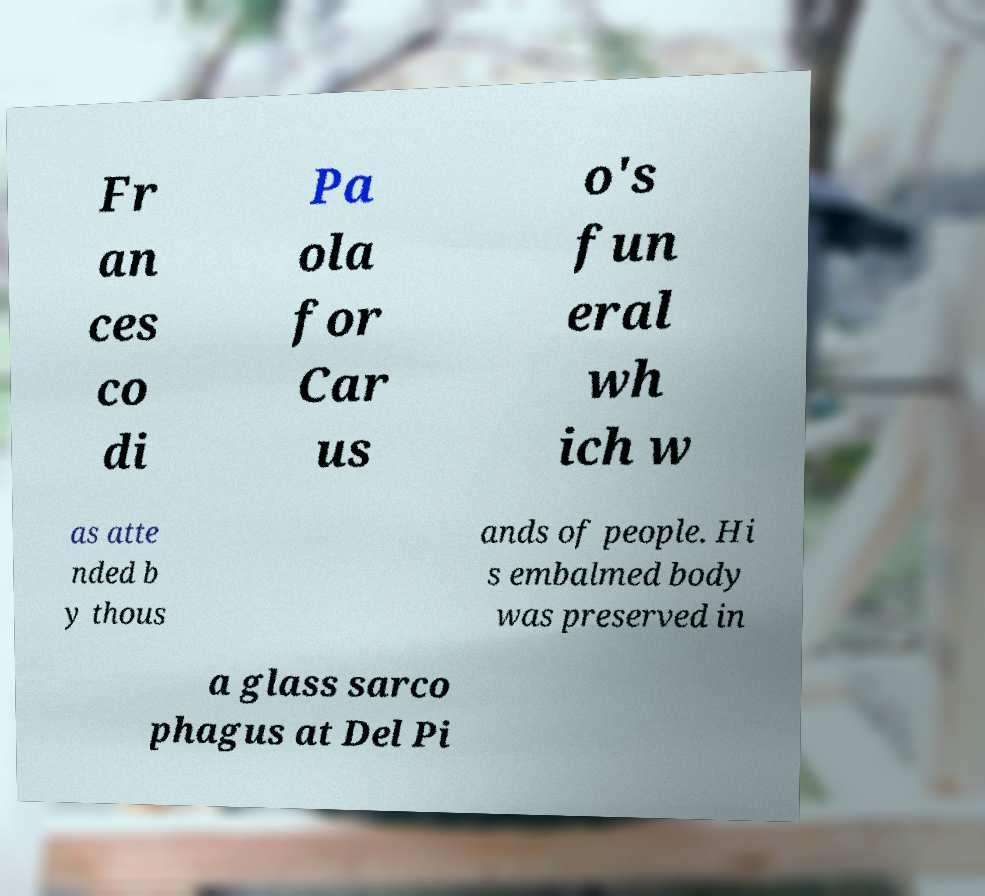What messages or text are displayed in this image? I need them in a readable, typed format. Fr an ces co di Pa ola for Car us o's fun eral wh ich w as atte nded b y thous ands of people. Hi s embalmed body was preserved in a glass sarco phagus at Del Pi 